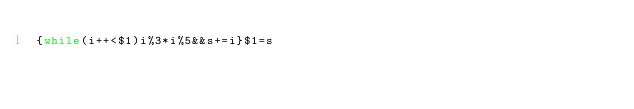Convert code to text. <code><loc_0><loc_0><loc_500><loc_500><_Awk_>{while(i++<$1)i%3*i%5&&s+=i}$1=s</code> 